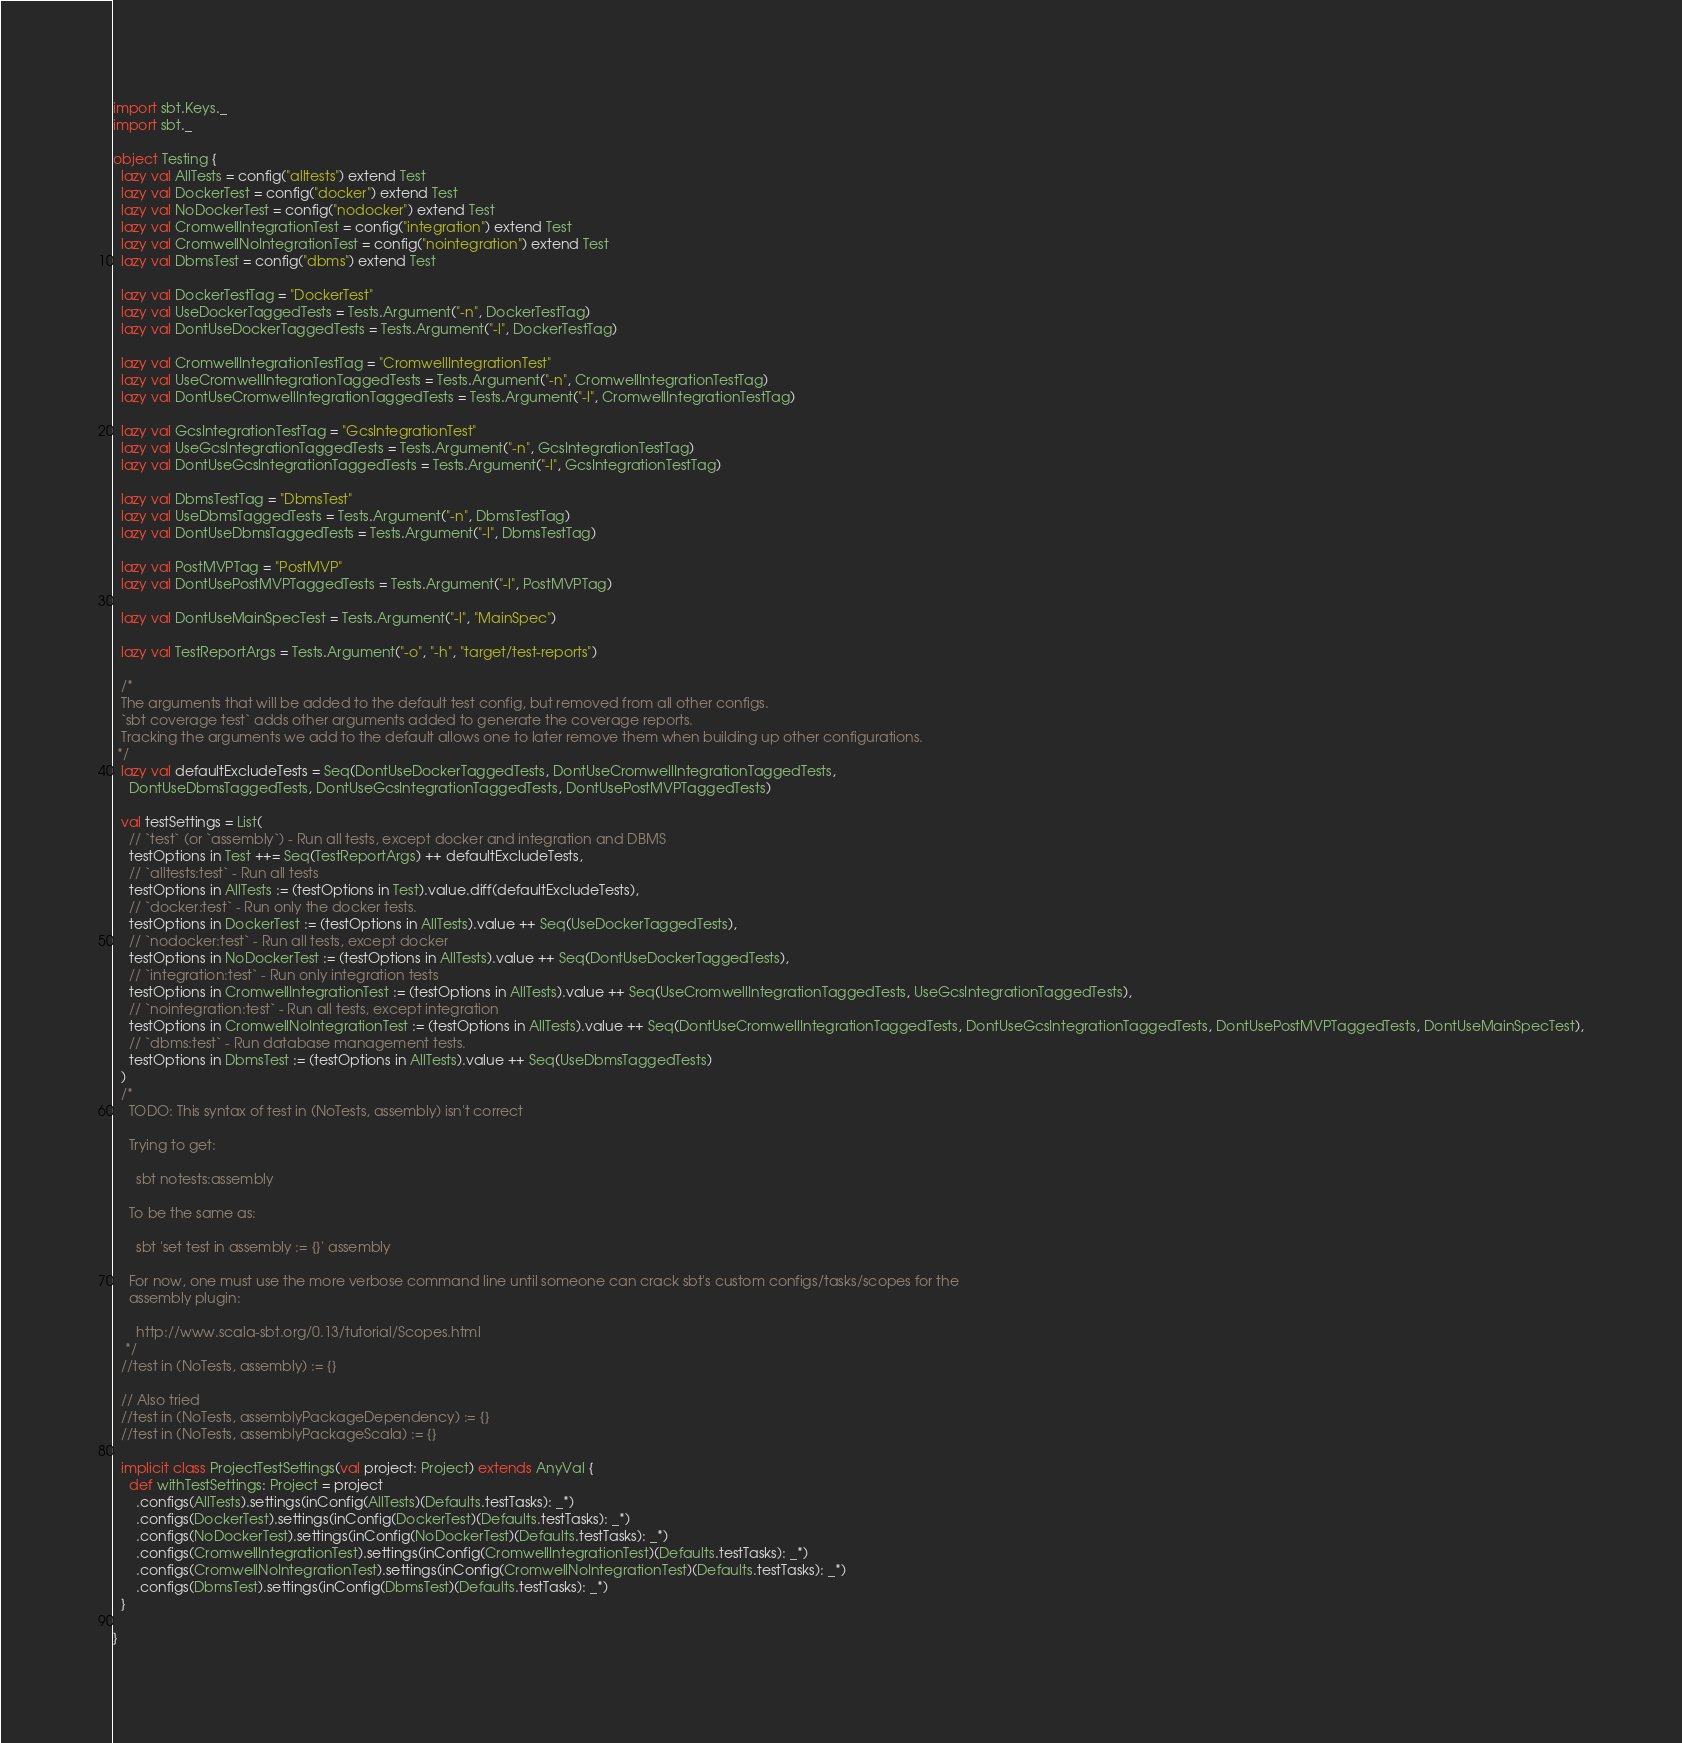<code> <loc_0><loc_0><loc_500><loc_500><_Scala_>import sbt.Keys._
import sbt._

object Testing {
  lazy val AllTests = config("alltests") extend Test
  lazy val DockerTest = config("docker") extend Test
  lazy val NoDockerTest = config("nodocker") extend Test
  lazy val CromwellIntegrationTest = config("integration") extend Test
  lazy val CromwellNoIntegrationTest = config("nointegration") extend Test
  lazy val DbmsTest = config("dbms") extend Test

  lazy val DockerTestTag = "DockerTest"
  lazy val UseDockerTaggedTests = Tests.Argument("-n", DockerTestTag)
  lazy val DontUseDockerTaggedTests = Tests.Argument("-l", DockerTestTag)

  lazy val CromwellIntegrationTestTag = "CromwellIntegrationTest"
  lazy val UseCromwellIntegrationTaggedTests = Tests.Argument("-n", CromwellIntegrationTestTag)
  lazy val DontUseCromwellIntegrationTaggedTests = Tests.Argument("-l", CromwellIntegrationTestTag)

  lazy val GcsIntegrationTestTag = "GcsIntegrationTest"
  lazy val UseGcsIntegrationTaggedTests = Tests.Argument("-n", GcsIntegrationTestTag)
  lazy val DontUseGcsIntegrationTaggedTests = Tests.Argument("-l", GcsIntegrationTestTag)

  lazy val DbmsTestTag = "DbmsTest"
  lazy val UseDbmsTaggedTests = Tests.Argument("-n", DbmsTestTag)
  lazy val DontUseDbmsTaggedTests = Tests.Argument("-l", DbmsTestTag)

  lazy val PostMVPTag = "PostMVP"
  lazy val DontUsePostMVPTaggedTests = Tests.Argument("-l", PostMVPTag)

  lazy val DontUseMainSpecTest = Tests.Argument("-l", "MainSpec")

  lazy val TestReportArgs = Tests.Argument("-o", "-h", "target/test-reports")

  /*
  The arguments that will be added to the default test config, but removed from all other configs.
  `sbt coverage test` adds other arguments added to generate the coverage reports.
  Tracking the arguments we add to the default allows one to later remove them when building up other configurations.
 */
  lazy val defaultExcludeTests = Seq(DontUseDockerTaggedTests, DontUseCromwellIntegrationTaggedTests,
    DontUseDbmsTaggedTests, DontUseGcsIntegrationTaggedTests, DontUsePostMVPTaggedTests)

  val testSettings = List(
    // `test` (or `assembly`) - Run all tests, except docker and integration and DBMS
    testOptions in Test ++= Seq(TestReportArgs) ++ defaultExcludeTests,
    // `alltests:test` - Run all tests
    testOptions in AllTests := (testOptions in Test).value.diff(defaultExcludeTests),
    // `docker:test` - Run only the docker tests.
    testOptions in DockerTest := (testOptions in AllTests).value ++ Seq(UseDockerTaggedTests),
    // `nodocker:test` - Run all tests, except docker
    testOptions in NoDockerTest := (testOptions in AllTests).value ++ Seq(DontUseDockerTaggedTests),
    // `integration:test` - Run only integration tests
    testOptions in CromwellIntegrationTest := (testOptions in AllTests).value ++ Seq(UseCromwellIntegrationTaggedTests, UseGcsIntegrationTaggedTests),
    // `nointegration:test` - Run all tests, except integration
    testOptions in CromwellNoIntegrationTest := (testOptions in AllTests).value ++ Seq(DontUseCromwellIntegrationTaggedTests, DontUseGcsIntegrationTaggedTests, DontUsePostMVPTaggedTests, DontUseMainSpecTest),
    // `dbms:test` - Run database management tests.
    testOptions in DbmsTest := (testOptions in AllTests).value ++ Seq(UseDbmsTaggedTests)
  )
  /*
    TODO: This syntax of test in (NoTests, assembly) isn't correct

    Trying to get:

      sbt notests:assembly

    To be the same as:

      sbt 'set test in assembly := {}' assembly

    For now, one must use the more verbose command line until someone can crack sbt's custom configs/tasks/scopes for the
    assembly plugin:

      http://www.scala-sbt.org/0.13/tutorial/Scopes.html
   */
  //test in (NoTests, assembly) := {}

  // Also tried
  //test in (NoTests, assemblyPackageDependency) := {}
  //test in (NoTests, assemblyPackageScala) := {}

  implicit class ProjectTestSettings(val project: Project) extends AnyVal {
    def withTestSettings: Project = project
      .configs(AllTests).settings(inConfig(AllTests)(Defaults.testTasks): _*)
      .configs(DockerTest).settings(inConfig(DockerTest)(Defaults.testTasks): _*)
      .configs(NoDockerTest).settings(inConfig(NoDockerTest)(Defaults.testTasks): _*)
      .configs(CromwellIntegrationTest).settings(inConfig(CromwellIntegrationTest)(Defaults.testTasks): _*)
      .configs(CromwellNoIntegrationTest).settings(inConfig(CromwellNoIntegrationTest)(Defaults.testTasks): _*)
      .configs(DbmsTest).settings(inConfig(DbmsTest)(Defaults.testTasks): _*)
  }

}
</code> 